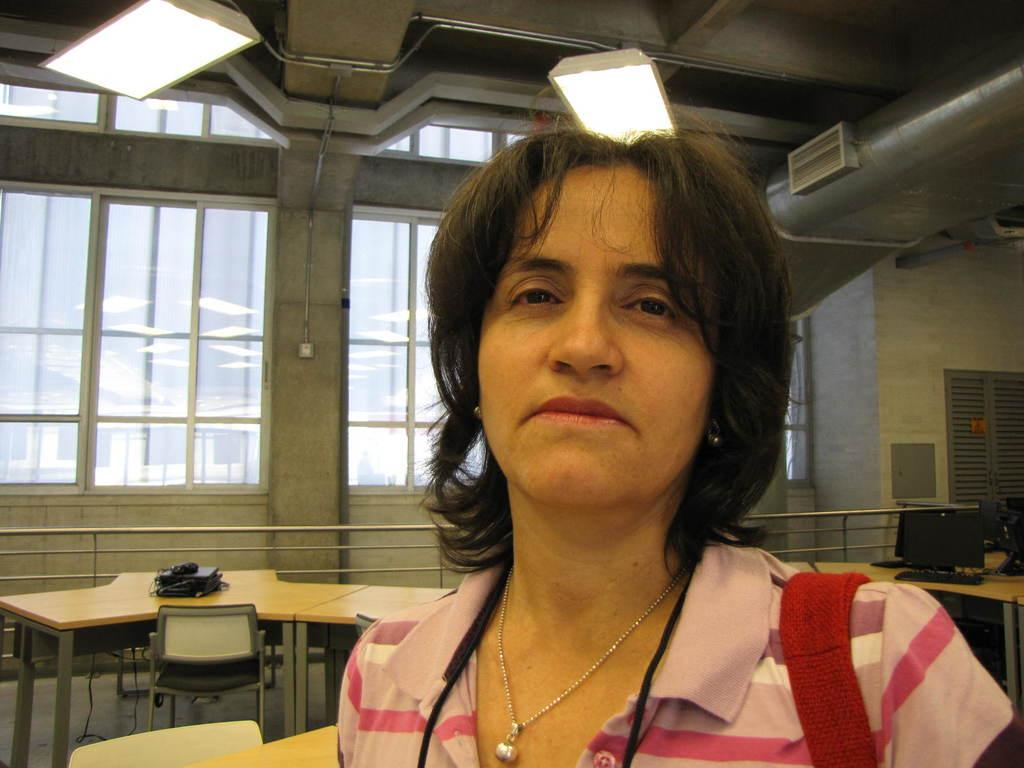Who is present in the image? There is a woman in the image. What type of furniture can be seen in the background of the image? There is a table and a chair in the background of the image. What architectural features are visible in the background of the image? There are windows in the background of the image. What type of illumination is present in the background of the image? There are lights in the background of the image. How many coils are visible on the woman's clothing in the image? There are no coils visible on the woman's clothing in the image. What type of transportation is present in the image? There is no transportation present in the image. 